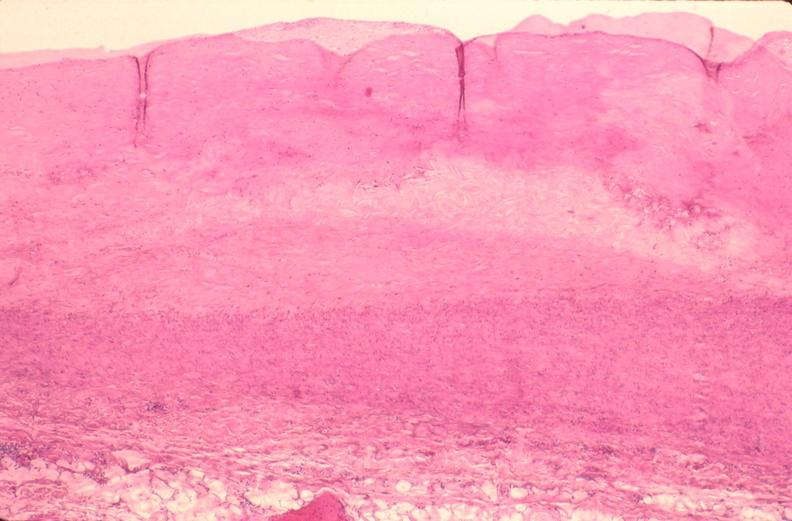what does this image show?
Answer the question using a single word or phrase. Pulmonary artery atherosclerosis in patient with pulmonary hypertension 